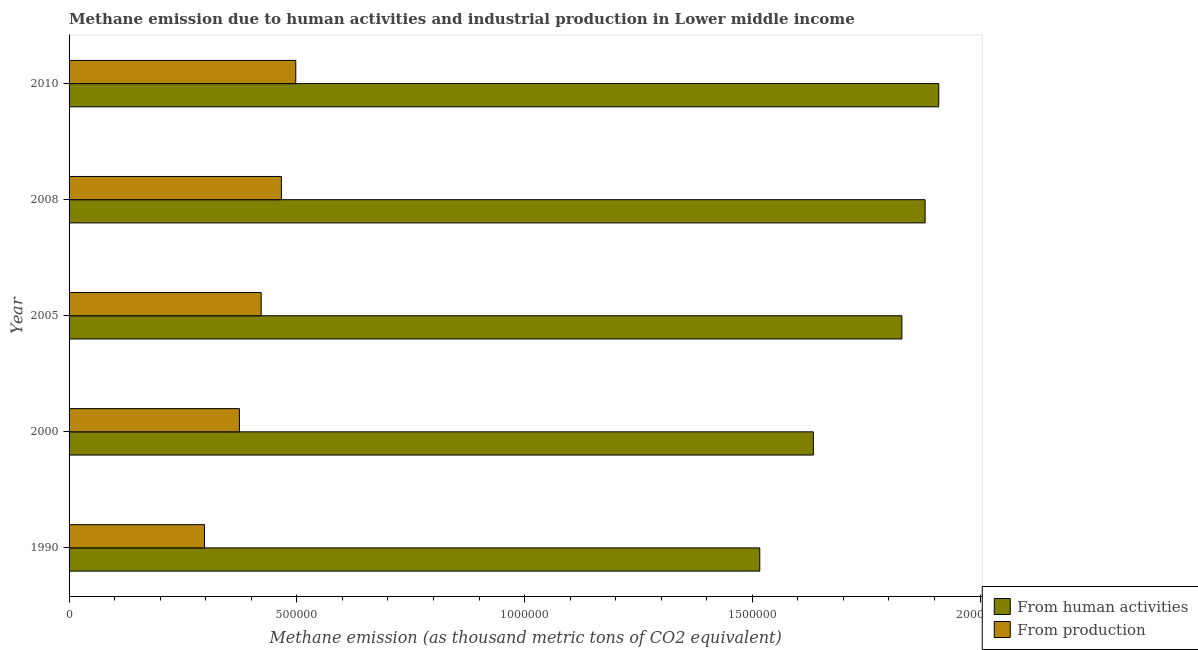How many bars are there on the 1st tick from the top?
Provide a succinct answer. 2. In how many cases, is the number of bars for a given year not equal to the number of legend labels?
Make the answer very short. 0. What is the amount of emissions from human activities in 2005?
Give a very brief answer. 1.83e+06. Across all years, what is the maximum amount of emissions from human activities?
Ensure brevity in your answer.  1.91e+06. Across all years, what is the minimum amount of emissions from human activities?
Provide a short and direct response. 1.52e+06. In which year was the amount of emissions from human activities minimum?
Keep it short and to the point. 1990. What is the total amount of emissions generated from industries in the graph?
Your answer should be compact. 2.06e+06. What is the difference between the amount of emissions generated from industries in 1990 and that in 2005?
Ensure brevity in your answer.  -1.24e+05. What is the difference between the amount of emissions from human activities in 2008 and the amount of emissions generated from industries in 1990?
Your answer should be very brief. 1.58e+06. What is the average amount of emissions generated from industries per year?
Keep it short and to the point. 4.11e+05. In the year 2005, what is the difference between the amount of emissions generated from industries and amount of emissions from human activities?
Your response must be concise. -1.41e+06. In how many years, is the amount of emissions from human activities greater than 1700000 thousand metric tons?
Your answer should be compact. 3. What is the ratio of the amount of emissions from human activities in 1990 to that in 2000?
Ensure brevity in your answer.  0.93. Is the amount of emissions generated from industries in 2005 less than that in 2010?
Make the answer very short. Yes. What is the difference between the highest and the second highest amount of emissions from human activities?
Your answer should be very brief. 3.00e+04. What is the difference between the highest and the lowest amount of emissions from human activities?
Give a very brief answer. 3.93e+05. What does the 2nd bar from the top in 1990 represents?
Ensure brevity in your answer.  From human activities. What does the 1st bar from the bottom in 2008 represents?
Ensure brevity in your answer.  From human activities. Are all the bars in the graph horizontal?
Your answer should be compact. Yes. How many years are there in the graph?
Your answer should be compact. 5. Are the values on the major ticks of X-axis written in scientific E-notation?
Provide a succinct answer. No. Does the graph contain grids?
Provide a short and direct response. No. How are the legend labels stacked?
Your response must be concise. Vertical. What is the title of the graph?
Provide a short and direct response. Methane emission due to human activities and industrial production in Lower middle income. What is the label or title of the X-axis?
Provide a short and direct response. Methane emission (as thousand metric tons of CO2 equivalent). What is the label or title of the Y-axis?
Provide a short and direct response. Year. What is the Methane emission (as thousand metric tons of CO2 equivalent) of From human activities in 1990?
Your answer should be very brief. 1.52e+06. What is the Methane emission (as thousand metric tons of CO2 equivalent) in From production in 1990?
Your answer should be compact. 2.97e+05. What is the Methane emission (as thousand metric tons of CO2 equivalent) in From human activities in 2000?
Ensure brevity in your answer.  1.63e+06. What is the Methane emission (as thousand metric tons of CO2 equivalent) in From production in 2000?
Your answer should be very brief. 3.74e+05. What is the Methane emission (as thousand metric tons of CO2 equivalent) in From human activities in 2005?
Provide a succinct answer. 1.83e+06. What is the Methane emission (as thousand metric tons of CO2 equivalent) in From production in 2005?
Keep it short and to the point. 4.22e+05. What is the Methane emission (as thousand metric tons of CO2 equivalent) in From human activities in 2008?
Your answer should be very brief. 1.88e+06. What is the Methane emission (as thousand metric tons of CO2 equivalent) in From production in 2008?
Provide a succinct answer. 4.66e+05. What is the Methane emission (as thousand metric tons of CO2 equivalent) in From human activities in 2010?
Offer a very short reply. 1.91e+06. What is the Methane emission (as thousand metric tons of CO2 equivalent) in From production in 2010?
Your response must be concise. 4.98e+05. Across all years, what is the maximum Methane emission (as thousand metric tons of CO2 equivalent) of From human activities?
Your response must be concise. 1.91e+06. Across all years, what is the maximum Methane emission (as thousand metric tons of CO2 equivalent) in From production?
Give a very brief answer. 4.98e+05. Across all years, what is the minimum Methane emission (as thousand metric tons of CO2 equivalent) of From human activities?
Provide a succinct answer. 1.52e+06. Across all years, what is the minimum Methane emission (as thousand metric tons of CO2 equivalent) of From production?
Ensure brevity in your answer.  2.97e+05. What is the total Methane emission (as thousand metric tons of CO2 equivalent) in From human activities in the graph?
Ensure brevity in your answer.  8.77e+06. What is the total Methane emission (as thousand metric tons of CO2 equivalent) in From production in the graph?
Provide a succinct answer. 2.06e+06. What is the difference between the Methane emission (as thousand metric tons of CO2 equivalent) in From human activities in 1990 and that in 2000?
Provide a succinct answer. -1.18e+05. What is the difference between the Methane emission (as thousand metric tons of CO2 equivalent) in From production in 1990 and that in 2000?
Your answer should be compact. -7.67e+04. What is the difference between the Methane emission (as thousand metric tons of CO2 equivalent) in From human activities in 1990 and that in 2005?
Make the answer very short. -3.12e+05. What is the difference between the Methane emission (as thousand metric tons of CO2 equivalent) in From production in 1990 and that in 2005?
Your answer should be very brief. -1.24e+05. What is the difference between the Methane emission (as thousand metric tons of CO2 equivalent) of From human activities in 1990 and that in 2008?
Keep it short and to the point. -3.63e+05. What is the difference between the Methane emission (as thousand metric tons of CO2 equivalent) of From production in 1990 and that in 2008?
Provide a short and direct response. -1.69e+05. What is the difference between the Methane emission (as thousand metric tons of CO2 equivalent) in From human activities in 1990 and that in 2010?
Give a very brief answer. -3.93e+05. What is the difference between the Methane emission (as thousand metric tons of CO2 equivalent) in From production in 1990 and that in 2010?
Your answer should be very brief. -2.00e+05. What is the difference between the Methane emission (as thousand metric tons of CO2 equivalent) of From human activities in 2000 and that in 2005?
Give a very brief answer. -1.94e+05. What is the difference between the Methane emission (as thousand metric tons of CO2 equivalent) of From production in 2000 and that in 2005?
Give a very brief answer. -4.78e+04. What is the difference between the Methane emission (as thousand metric tons of CO2 equivalent) of From human activities in 2000 and that in 2008?
Give a very brief answer. -2.45e+05. What is the difference between the Methane emission (as thousand metric tons of CO2 equivalent) in From production in 2000 and that in 2008?
Your answer should be compact. -9.21e+04. What is the difference between the Methane emission (as thousand metric tons of CO2 equivalent) in From human activities in 2000 and that in 2010?
Your answer should be compact. -2.75e+05. What is the difference between the Methane emission (as thousand metric tons of CO2 equivalent) in From production in 2000 and that in 2010?
Provide a succinct answer. -1.24e+05. What is the difference between the Methane emission (as thousand metric tons of CO2 equivalent) in From human activities in 2005 and that in 2008?
Offer a very short reply. -5.09e+04. What is the difference between the Methane emission (as thousand metric tons of CO2 equivalent) in From production in 2005 and that in 2008?
Your answer should be very brief. -4.44e+04. What is the difference between the Methane emission (as thousand metric tons of CO2 equivalent) of From human activities in 2005 and that in 2010?
Your answer should be compact. -8.09e+04. What is the difference between the Methane emission (as thousand metric tons of CO2 equivalent) in From production in 2005 and that in 2010?
Offer a very short reply. -7.59e+04. What is the difference between the Methane emission (as thousand metric tons of CO2 equivalent) of From human activities in 2008 and that in 2010?
Offer a very short reply. -3.00e+04. What is the difference between the Methane emission (as thousand metric tons of CO2 equivalent) of From production in 2008 and that in 2010?
Ensure brevity in your answer.  -3.16e+04. What is the difference between the Methane emission (as thousand metric tons of CO2 equivalent) of From human activities in 1990 and the Methane emission (as thousand metric tons of CO2 equivalent) of From production in 2000?
Ensure brevity in your answer.  1.14e+06. What is the difference between the Methane emission (as thousand metric tons of CO2 equivalent) of From human activities in 1990 and the Methane emission (as thousand metric tons of CO2 equivalent) of From production in 2005?
Your answer should be compact. 1.09e+06. What is the difference between the Methane emission (as thousand metric tons of CO2 equivalent) of From human activities in 1990 and the Methane emission (as thousand metric tons of CO2 equivalent) of From production in 2008?
Provide a short and direct response. 1.05e+06. What is the difference between the Methane emission (as thousand metric tons of CO2 equivalent) in From human activities in 1990 and the Methane emission (as thousand metric tons of CO2 equivalent) in From production in 2010?
Your answer should be compact. 1.02e+06. What is the difference between the Methane emission (as thousand metric tons of CO2 equivalent) of From human activities in 2000 and the Methane emission (as thousand metric tons of CO2 equivalent) of From production in 2005?
Your answer should be very brief. 1.21e+06. What is the difference between the Methane emission (as thousand metric tons of CO2 equivalent) in From human activities in 2000 and the Methane emission (as thousand metric tons of CO2 equivalent) in From production in 2008?
Make the answer very short. 1.17e+06. What is the difference between the Methane emission (as thousand metric tons of CO2 equivalent) of From human activities in 2000 and the Methane emission (as thousand metric tons of CO2 equivalent) of From production in 2010?
Your response must be concise. 1.14e+06. What is the difference between the Methane emission (as thousand metric tons of CO2 equivalent) of From human activities in 2005 and the Methane emission (as thousand metric tons of CO2 equivalent) of From production in 2008?
Provide a short and direct response. 1.36e+06. What is the difference between the Methane emission (as thousand metric tons of CO2 equivalent) in From human activities in 2005 and the Methane emission (as thousand metric tons of CO2 equivalent) in From production in 2010?
Make the answer very short. 1.33e+06. What is the difference between the Methane emission (as thousand metric tons of CO2 equivalent) of From human activities in 2008 and the Methane emission (as thousand metric tons of CO2 equivalent) of From production in 2010?
Give a very brief answer. 1.38e+06. What is the average Methane emission (as thousand metric tons of CO2 equivalent) in From human activities per year?
Your answer should be very brief. 1.75e+06. What is the average Methane emission (as thousand metric tons of CO2 equivalent) of From production per year?
Offer a very short reply. 4.11e+05. In the year 1990, what is the difference between the Methane emission (as thousand metric tons of CO2 equivalent) of From human activities and Methane emission (as thousand metric tons of CO2 equivalent) of From production?
Give a very brief answer. 1.22e+06. In the year 2000, what is the difference between the Methane emission (as thousand metric tons of CO2 equivalent) in From human activities and Methane emission (as thousand metric tons of CO2 equivalent) in From production?
Keep it short and to the point. 1.26e+06. In the year 2005, what is the difference between the Methane emission (as thousand metric tons of CO2 equivalent) in From human activities and Methane emission (as thousand metric tons of CO2 equivalent) in From production?
Offer a very short reply. 1.41e+06. In the year 2008, what is the difference between the Methane emission (as thousand metric tons of CO2 equivalent) of From human activities and Methane emission (as thousand metric tons of CO2 equivalent) of From production?
Provide a succinct answer. 1.41e+06. In the year 2010, what is the difference between the Methane emission (as thousand metric tons of CO2 equivalent) of From human activities and Methane emission (as thousand metric tons of CO2 equivalent) of From production?
Provide a succinct answer. 1.41e+06. What is the ratio of the Methane emission (as thousand metric tons of CO2 equivalent) of From human activities in 1990 to that in 2000?
Offer a very short reply. 0.93. What is the ratio of the Methane emission (as thousand metric tons of CO2 equivalent) of From production in 1990 to that in 2000?
Provide a succinct answer. 0.79. What is the ratio of the Methane emission (as thousand metric tons of CO2 equivalent) of From human activities in 1990 to that in 2005?
Give a very brief answer. 0.83. What is the ratio of the Methane emission (as thousand metric tons of CO2 equivalent) of From production in 1990 to that in 2005?
Make the answer very short. 0.7. What is the ratio of the Methane emission (as thousand metric tons of CO2 equivalent) of From human activities in 1990 to that in 2008?
Keep it short and to the point. 0.81. What is the ratio of the Methane emission (as thousand metric tons of CO2 equivalent) of From production in 1990 to that in 2008?
Offer a very short reply. 0.64. What is the ratio of the Methane emission (as thousand metric tons of CO2 equivalent) in From human activities in 1990 to that in 2010?
Keep it short and to the point. 0.79. What is the ratio of the Methane emission (as thousand metric tons of CO2 equivalent) of From production in 1990 to that in 2010?
Your answer should be very brief. 0.6. What is the ratio of the Methane emission (as thousand metric tons of CO2 equivalent) of From human activities in 2000 to that in 2005?
Provide a short and direct response. 0.89. What is the ratio of the Methane emission (as thousand metric tons of CO2 equivalent) in From production in 2000 to that in 2005?
Give a very brief answer. 0.89. What is the ratio of the Methane emission (as thousand metric tons of CO2 equivalent) in From human activities in 2000 to that in 2008?
Give a very brief answer. 0.87. What is the ratio of the Methane emission (as thousand metric tons of CO2 equivalent) in From production in 2000 to that in 2008?
Make the answer very short. 0.8. What is the ratio of the Methane emission (as thousand metric tons of CO2 equivalent) in From human activities in 2000 to that in 2010?
Ensure brevity in your answer.  0.86. What is the ratio of the Methane emission (as thousand metric tons of CO2 equivalent) in From production in 2000 to that in 2010?
Provide a succinct answer. 0.75. What is the ratio of the Methane emission (as thousand metric tons of CO2 equivalent) in From human activities in 2005 to that in 2008?
Offer a very short reply. 0.97. What is the ratio of the Methane emission (as thousand metric tons of CO2 equivalent) of From production in 2005 to that in 2008?
Give a very brief answer. 0.9. What is the ratio of the Methane emission (as thousand metric tons of CO2 equivalent) of From human activities in 2005 to that in 2010?
Your response must be concise. 0.96. What is the ratio of the Methane emission (as thousand metric tons of CO2 equivalent) of From production in 2005 to that in 2010?
Your answer should be compact. 0.85. What is the ratio of the Methane emission (as thousand metric tons of CO2 equivalent) in From human activities in 2008 to that in 2010?
Provide a succinct answer. 0.98. What is the ratio of the Methane emission (as thousand metric tons of CO2 equivalent) in From production in 2008 to that in 2010?
Offer a very short reply. 0.94. What is the difference between the highest and the second highest Methane emission (as thousand metric tons of CO2 equivalent) of From human activities?
Your answer should be compact. 3.00e+04. What is the difference between the highest and the second highest Methane emission (as thousand metric tons of CO2 equivalent) in From production?
Offer a terse response. 3.16e+04. What is the difference between the highest and the lowest Methane emission (as thousand metric tons of CO2 equivalent) in From human activities?
Provide a short and direct response. 3.93e+05. What is the difference between the highest and the lowest Methane emission (as thousand metric tons of CO2 equivalent) in From production?
Your response must be concise. 2.00e+05. 